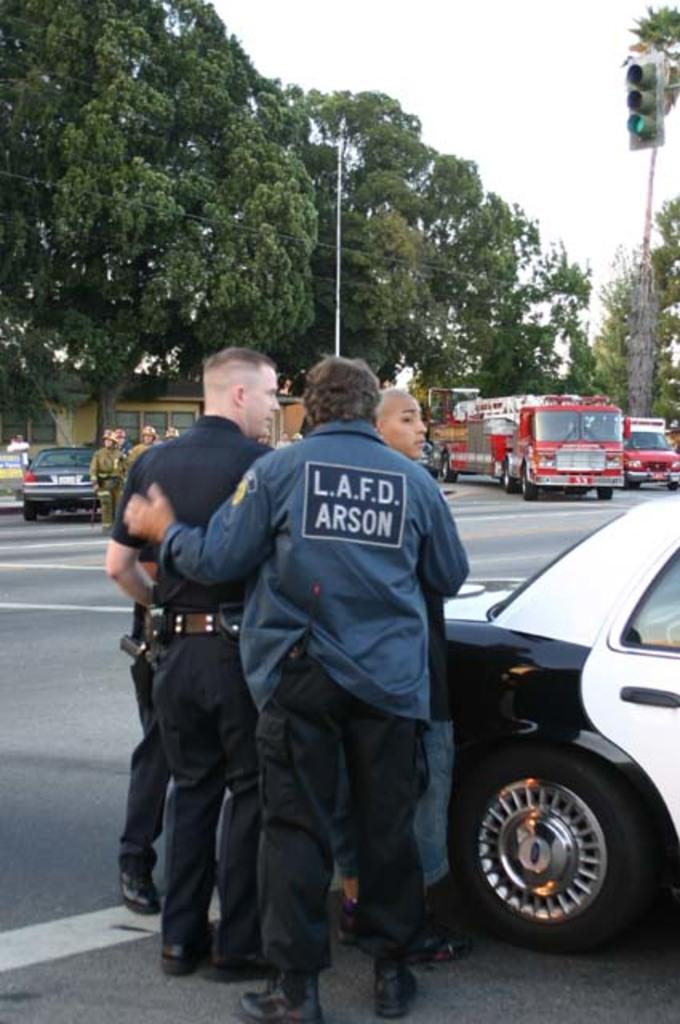What can be seen in the image involving people? There are people standing in the image. What is present on the road in the image? There are vehicles on the road in the image. What type of structure is visible in the image? There is a building in the image. What other natural elements can be seen in the image? There are trees in the image. What device is used to control traffic in the image? A: There is a traffic signal light in the image. What vertical object is present in the image? There is a pole in the image. How would you describe the weather based on the image? The sky is cloudy in the image. Reasoning: Let' Let's think step by step in order to produce the conversation. We start by identifying the main subjects and objects in the image based on the provided facts. We then formulate questions that focus on the location and characteristics of these subjects and objects, ensuring that each question can be answered definitively with the information given. We avoid yes/no questions and ensure that the language is simple and clear. Absurd Question/Answer: Where is the volleyball court located in the image? There is no volleyball court present in the image. What type of stage can be seen in the image? There is no stage present in the image. Can you see an airplane flying in the image? There is no airplane visible in the image. What type of stage can be seen in the image? There is no stage present in the image. 